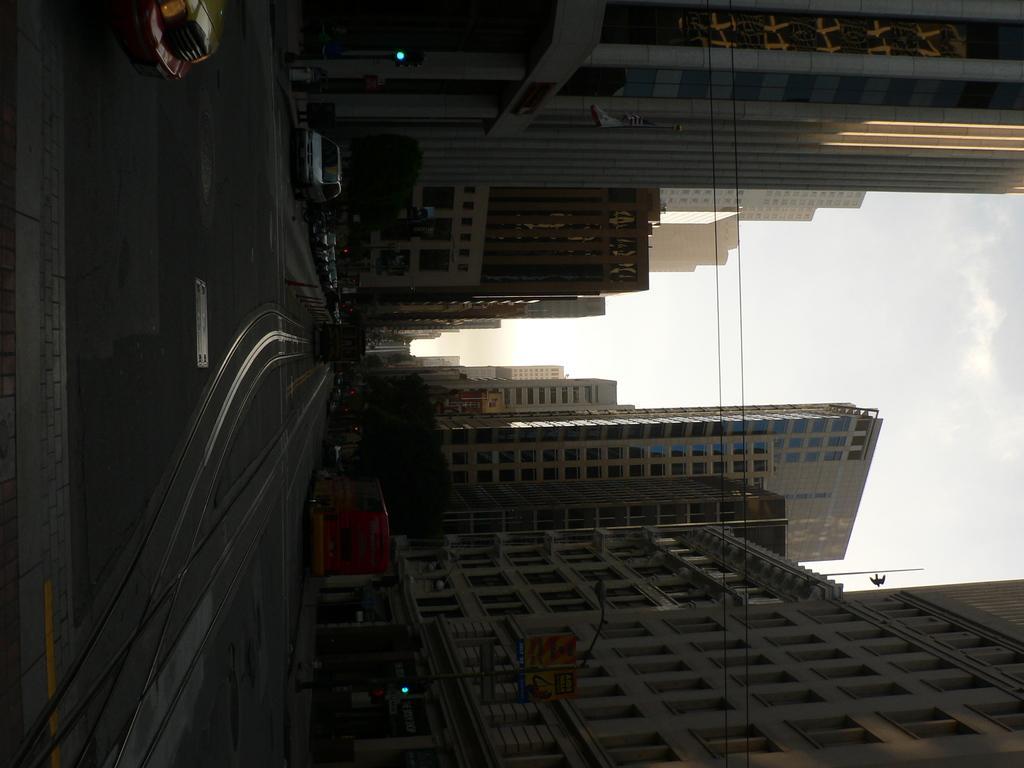In one or two sentences, can you explain what this image depicts? In this image there is a road. There is sky at the top. There are buildings, trees and vehicles. 